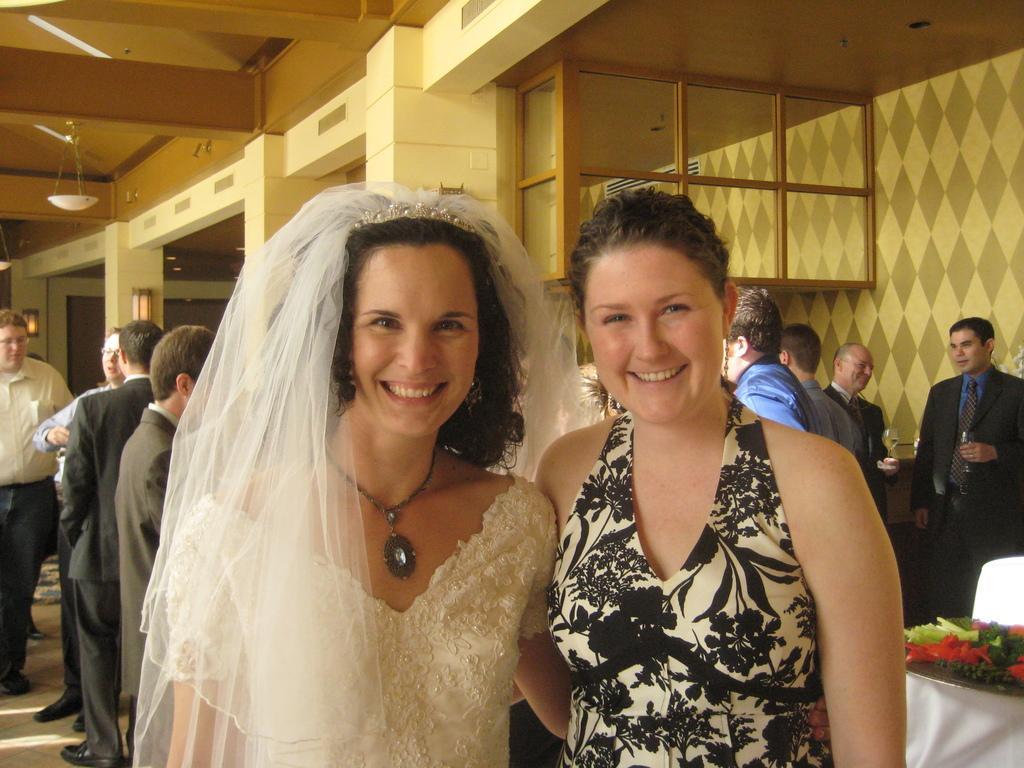How would you summarize this image in a sentence or two? In this image we can see two women. In the background there are few persons, food items in the plate on a platform, lights on the pillars, an object hanging to the ceiling and designs on the wall. 